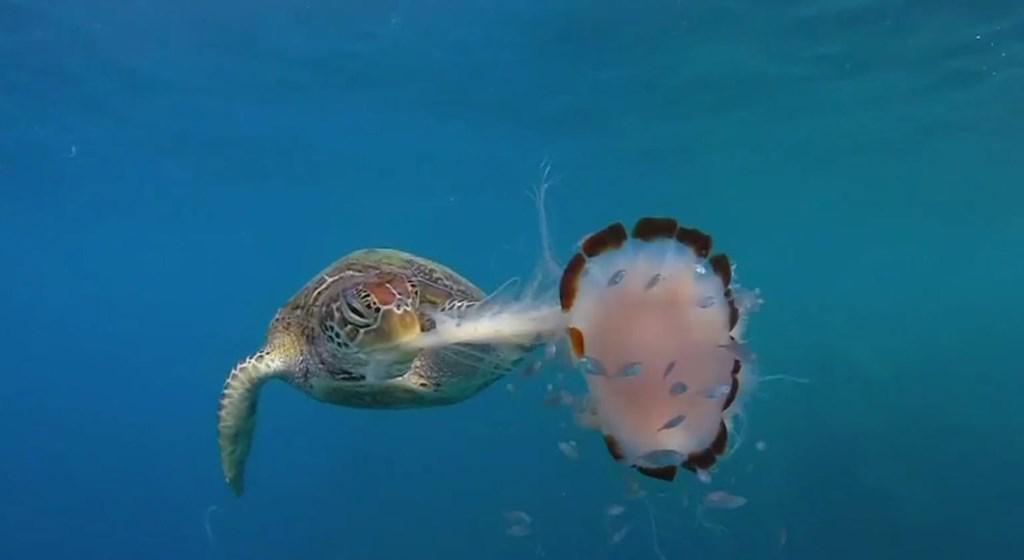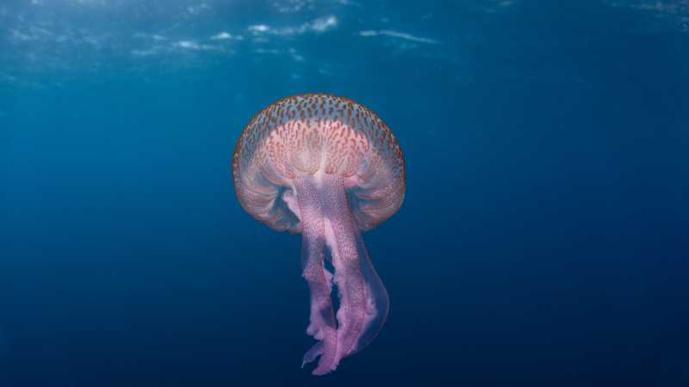The first image is the image on the left, the second image is the image on the right. For the images shown, is this caption "All jellyfish are at least partially above the water surface." true? Answer yes or no. No. The first image is the image on the left, the second image is the image on the right. Evaluate the accuracy of this statement regarding the images: "In one image, a single jelly fish skims the top of the water with the sky in the background.". Is it true? Answer yes or no. No. 